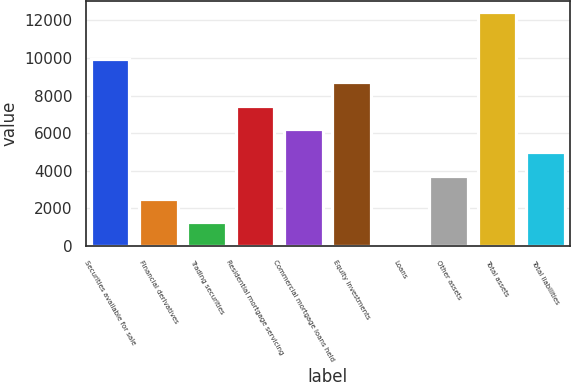Convert chart. <chart><loc_0><loc_0><loc_500><loc_500><bar_chart><fcel>Securities available for sale<fcel>Financial derivatives<fcel>Trading securities<fcel>Residential mortgage servicing<fcel>Commercial mortgage loans held<fcel>Equity investments<fcel>Loans<fcel>Other assets<fcel>Total assets<fcel>Total liabilities<nl><fcel>9942.8<fcel>2487.2<fcel>1244.6<fcel>7457.6<fcel>6215<fcel>8700.2<fcel>2<fcel>3729.8<fcel>12428<fcel>4972.4<nl></chart> 